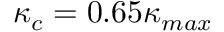<formula> <loc_0><loc_0><loc_500><loc_500>\kappa _ { c } = 0 . 6 5 \kappa _ { \max }</formula> 